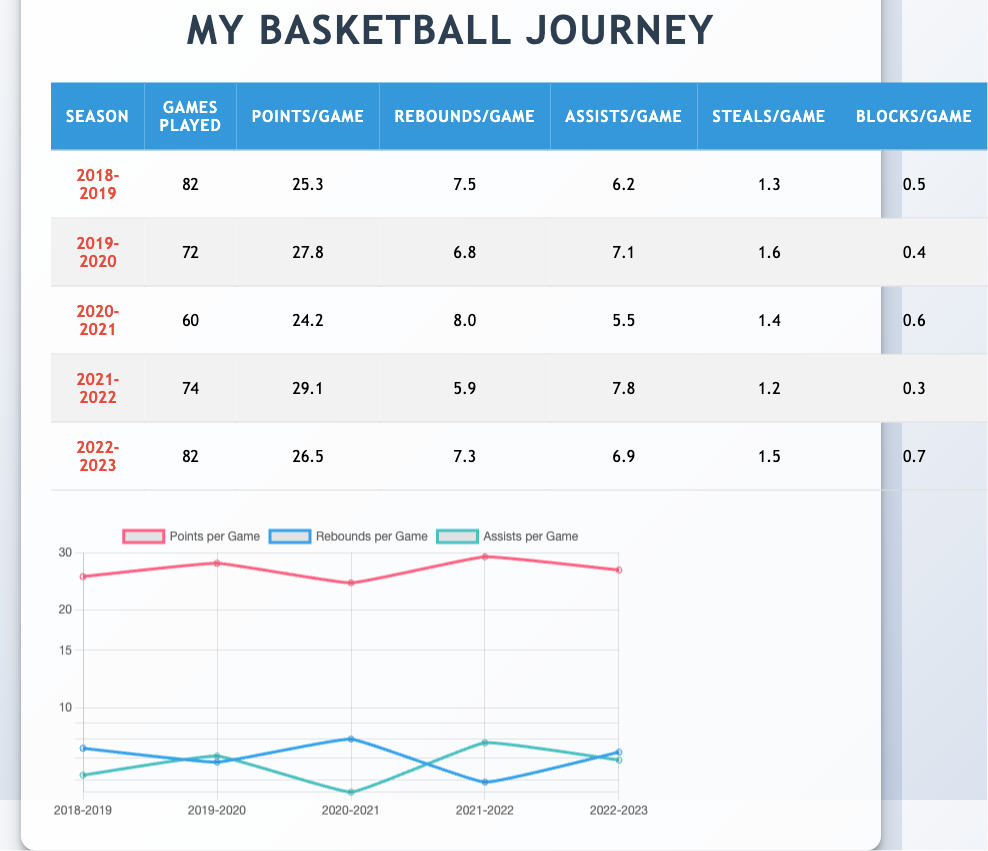What was the highest Points Per Game achieved by the player? By reviewing the table, I can see the Points Per Game for each season. The values are 25.3, 27.8, 24.2, 29.1, and 26.5. The highest among these is 29.1, which occurred in the 2021-2022 season.
Answer: 29.1 Did the player average more than 25 Points Per Game in the 2019-2020 season? The Points Per Game for the 2019-2020 season is 27.8. Since 27.8 is greater than 25, the answer is yes.
Answer: Yes What was the total number of Games Played across all seasons? To find the total Games Played, I will sum the number of games from each season: 82 + 72 + 60 + 74 + 82 = 370.
Answer: 370 In which season did the player record the highest average for Rebounds Per Game? Analyzing the table, the Rebounds Per Game for the seasons are 7.5, 6.8, 8.0, 5.9, and 7.3. The highest value is 8.0, which occurred in the 2020-2021 season.
Answer: 2020-2021 What is the average Assists Per Game across all seasons? To calculate the average Assists Per Game, I need to sum the assists: 6.2 + 7.1 + 5.5 + 7.8 + 6.9 = 33.5. Then, I divide by the number of seasons (5) to get 33.5 / 5 = 6.7.
Answer: 6.7 Was there a season where the player had more Steals Per Game than Blocks Per Game? I will check each season to compare the Steals Per Game and Blocks Per Game. The values are as follows: (1.3 vs 0.5), (1.6 vs 0.4), (1.4 vs 0.6), (1.2 vs 0.3), and (1.5 vs 0.7). All seasons show that Steals exceed Blocks, so the answer is yes.
Answer: Yes Which season had the lowest average for Points Per Game? By looking at the Points Per Game values, they are 25.3, 27.8, 24.2, 29.1, and 26.5. The lowest value is 24.2, which is from the 2020-2021 season.
Answer: 2020-2021 How many more Points Per Game did the player average in the 2021-2022 season compared to the 2020-2021 season? The Points Per Game for 2021-2022 is 29.1, and for 2020-2021 it is 24.2. I will calculate the difference: 29.1 - 24.2 = 4.9.
Answer: 4.9 